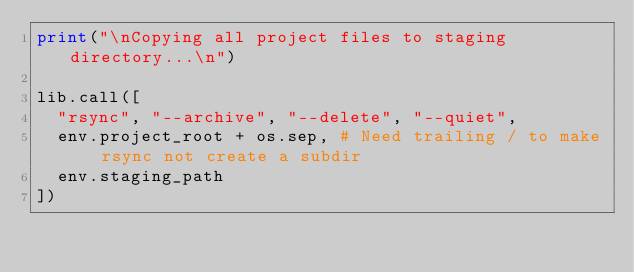<code> <loc_0><loc_0><loc_500><loc_500><_Python_>print("\nCopying all project files to staging directory...\n")

lib.call([
  "rsync", "--archive", "--delete", "--quiet",
  env.project_root + os.sep, # Need trailing / to make rsync not create a subdir
  env.staging_path
])
</code> 